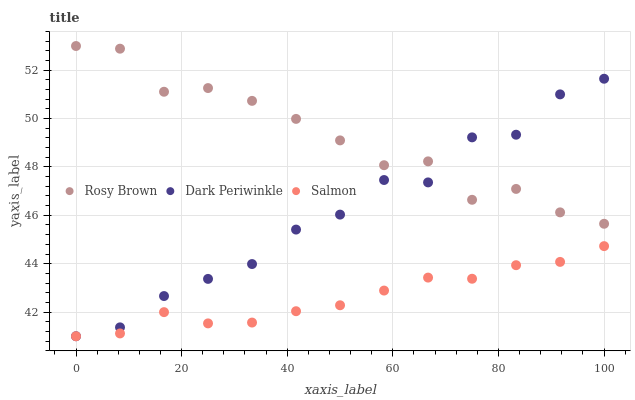Does Salmon have the minimum area under the curve?
Answer yes or no. Yes. Does Rosy Brown have the maximum area under the curve?
Answer yes or no. Yes. Does Dark Periwinkle have the minimum area under the curve?
Answer yes or no. No. Does Dark Periwinkle have the maximum area under the curve?
Answer yes or no. No. Is Salmon the smoothest?
Answer yes or no. Yes. Is Dark Periwinkle the roughest?
Answer yes or no. Yes. Is Dark Periwinkle the smoothest?
Answer yes or no. No. Is Salmon the roughest?
Answer yes or no. No. Does Salmon have the lowest value?
Answer yes or no. Yes. Does Rosy Brown have the highest value?
Answer yes or no. Yes. Does Dark Periwinkle have the highest value?
Answer yes or no. No. Is Salmon less than Rosy Brown?
Answer yes or no. Yes. Is Rosy Brown greater than Salmon?
Answer yes or no. Yes. Does Dark Periwinkle intersect Rosy Brown?
Answer yes or no. Yes. Is Dark Periwinkle less than Rosy Brown?
Answer yes or no. No. Is Dark Periwinkle greater than Rosy Brown?
Answer yes or no. No. Does Salmon intersect Rosy Brown?
Answer yes or no. No. 